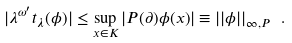Convert formula to latex. <formula><loc_0><loc_0><loc_500><loc_500>| \lambda ^ { \omega ^ { \prime } } t _ { \lambda } ( \phi ) | \leq \sup _ { x \in K } | P ( \partial ) \phi ( x ) | \equiv | | \phi | | _ { \infty , P } \ .</formula> 